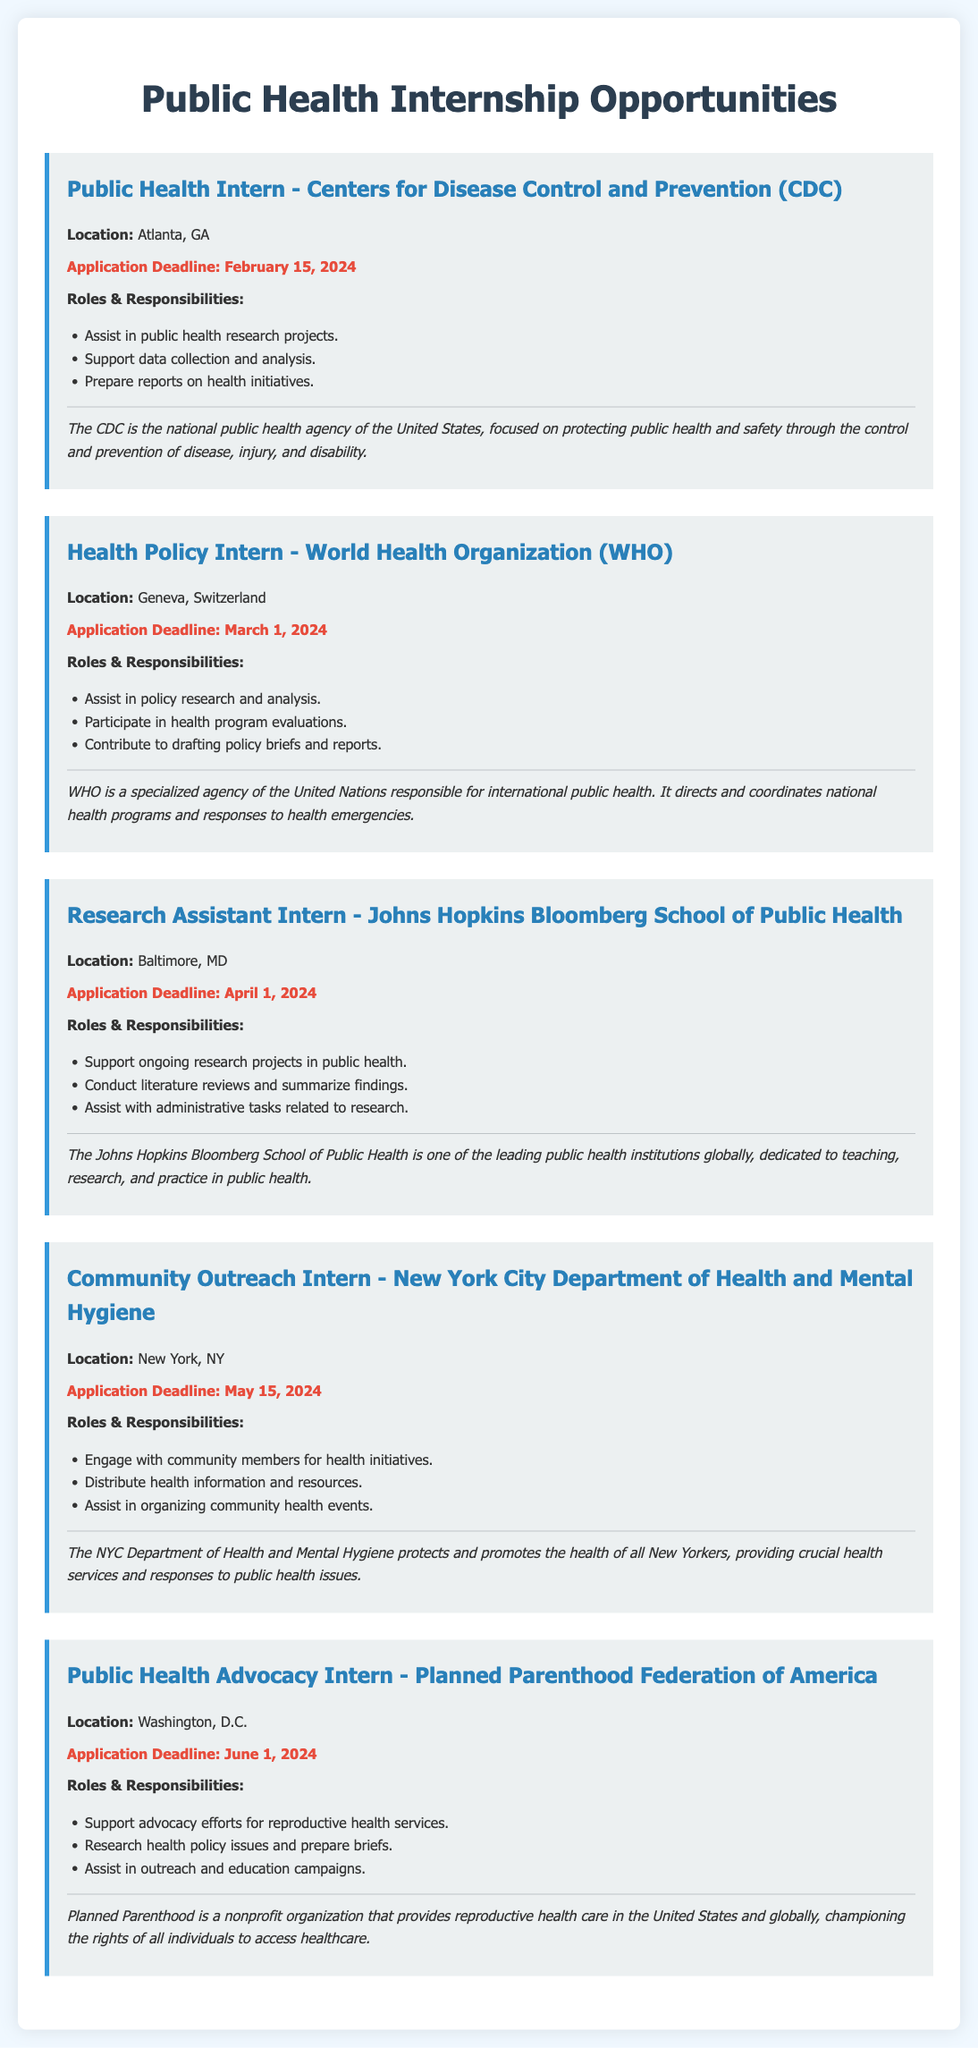What is the application deadline for the Public Health Intern position at CDC? The application deadline for the Public Health Intern position at CDC is February 15, 2024.
Answer: February 15, 2024 Where is the Health Policy Intern position located? The Health Policy Intern position is located in Geneva, Switzerland.
Answer: Geneva, Switzerland Which organization is offering a Research Assistant Intern position? The organization offering a Research Assistant Intern position is Johns Hopkins Bloomberg School of Public Health.
Answer: Johns Hopkins Bloomberg School of Public Health What is one responsibility of the Community Outreach Intern? One responsibility of the Community Outreach Intern is to engage with community members for health initiatives.
Answer: Engage with community members for health initiatives What is the deadline for the Public Health Advocacy Intern application? The deadline for the Public Health Advocacy Intern application is June 1, 2024.
Answer: June 1, 2024 How many internship opportunities are listed in the document? The document lists five internship opportunities.
Answer: Five What type of agency is the CDC? The CDC is the national public health agency of the United States.
Answer: National public health agency Which internship focuses on reproductive health services? The internship that focuses on reproductive health services is the Public Health Advocacy Intern at Planned Parenthood Federation of America.
Answer: Public Health Advocacy Intern at Planned Parenthood Federation of America What role involves conducting literature reviews? The role that involves conducting literature reviews is the Research Assistant Intern position.
Answer: Research Assistant Intern position 